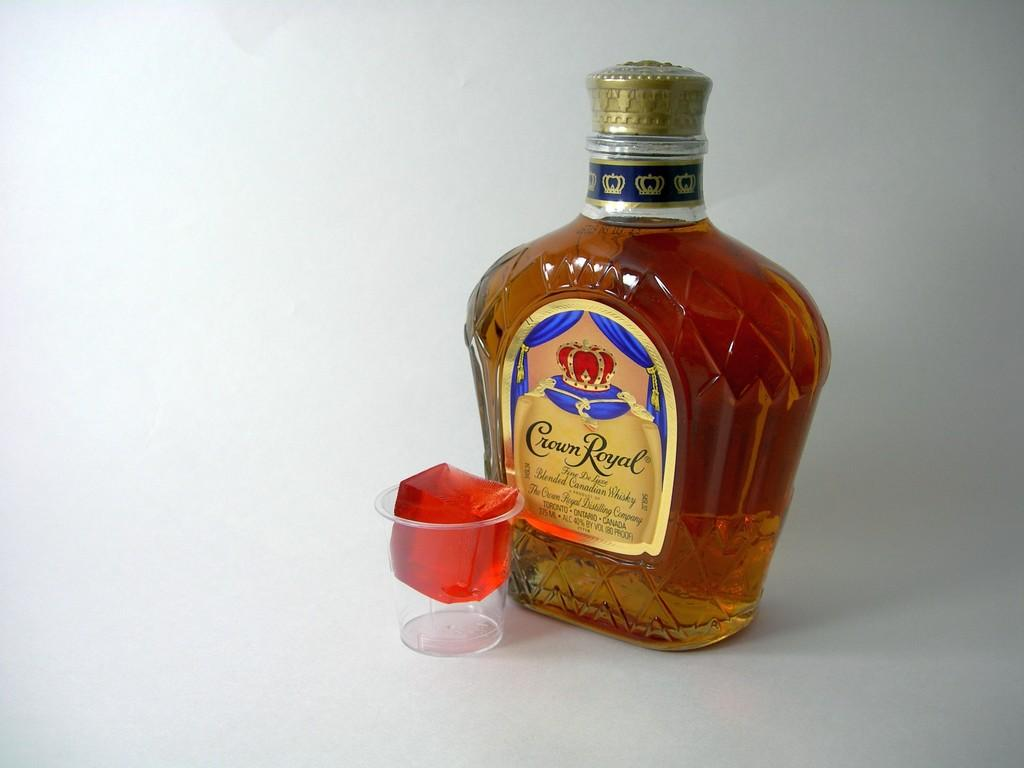<image>
Create a compact narrative representing the image presented. A bottle of Crown Royale rests next to a shot glass. 